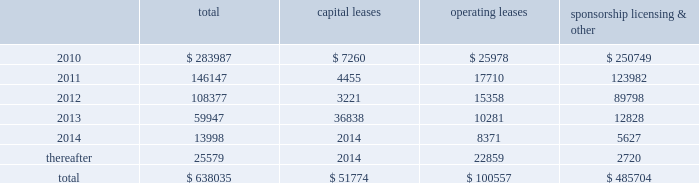Mastercard incorporated notes to consolidated financial statements 2014 ( continued ) ( in thousands , except percent and per share data ) equity awards was $ 30333 , $ 20726 and $ 19828 for the years ended december 31 , 2009 , 2008 and 2007 , respectively .
The income tax benefit related to options exercised during 2009 was $ 7545 .
The additional paid-in capital balance attributed to the equity awards was $ 197350 , $ 135538 and $ 114637 as of december 31 , 2009 , 2008 and 2007 , respectively .
On july 18 , 2006 , the company 2019s stockholders approved the mastercard incorporated 2006 non-employee director equity compensation plan ( the 201cdirector plan 201d ) .
The director plan provides for awards of deferred stock units ( 201cdsus 201d ) to each director of the company who is not a current employee of the company .
There are 100 shares of class a common stock reserved for dsu awards under the director plan .
During the years ended december 31 , 2009 , 2008 and 2007 , the company granted 7 dsus , 4 dsus and 8 dsus , respectively .
The fair value of the dsus was based on the closing stock price on the new york stock exchange of the company 2019s class a common stock on the date of grant .
The weighted average grant-date fair value of dsus granted during the years ended december 31 , 2009 , 2008 and 2007 was $ 168.18 , $ 284.92 and $ 139.27 , respectively .
The dsus vested immediately upon grant and will be settled in shares of the company 2019s class a common stock on the fourth anniversary of the date of grant .
Accordingly , the company recorded general and administrative expense of $ 1151 , $ 1209 and $ 1051 for the dsus for the years ended december 31 , 2009 , 2008 and 2007 , respectively .
The total income tax benefit recognized in the income statement for dsus was $ 410 , $ 371 and $ 413 for the years ended december 31 , 2009 , 2008 and 2007 , respectively .
Note 18 .
Commitments at december 31 , 2009 , the company had the following future minimum payments due under non-cancelable agreements : capital leases operating leases sponsorship , licensing & .
Included in the table above are capital leases with imputed interest expense of $ 7929 and a net present value of minimum lease payments of $ 43845 .
In addition , at december 31 , 2009 , $ 63616 of the future minimum payments in the table above for leases , sponsorship , licensing and other agreements was accrued .
Consolidated rental expense for the company 2019s office space , which is recognized on a straight line basis over the life of the lease , was approximately $ 39586 , $ 42905 and $ 35614 for the years ended december 31 , 2009 , 2008 and 2007 , respectively .
Consolidated lease expense for automobiles , computer equipment and office equipment was $ 9137 , $ 7694 and $ 7679 for the years ended december 31 , 2009 , 2008 and 2007 , respectively .
In january 2003 , mastercard purchased a building in kansas city , missouri for approximately $ 23572 .
The building is a co-processing data center which replaced a back-up data center in lake success , new york .
During 2003 , mastercard entered into agreements with the city of kansas city for ( i ) the sale-leaseback of the building and related equipment which totaled $ 36382 and ( ii ) the purchase of municipal bonds for the same amount .
What is the average value of operating leases during 2010-2014? 
Rationale: it is the sum of all operating leases during this period divided by six .
Computations: (100557 / 6)
Answer: 16759.5. Mastercard incorporated notes to consolidated financial statements 2014 ( continued ) ( in thousands , except percent and per share data ) equity awards was $ 30333 , $ 20726 and $ 19828 for the years ended december 31 , 2009 , 2008 and 2007 , respectively .
The income tax benefit related to options exercised during 2009 was $ 7545 .
The additional paid-in capital balance attributed to the equity awards was $ 197350 , $ 135538 and $ 114637 as of december 31 , 2009 , 2008 and 2007 , respectively .
On july 18 , 2006 , the company 2019s stockholders approved the mastercard incorporated 2006 non-employee director equity compensation plan ( the 201cdirector plan 201d ) .
The director plan provides for awards of deferred stock units ( 201cdsus 201d ) to each director of the company who is not a current employee of the company .
There are 100 shares of class a common stock reserved for dsu awards under the director plan .
During the years ended december 31 , 2009 , 2008 and 2007 , the company granted 7 dsus , 4 dsus and 8 dsus , respectively .
The fair value of the dsus was based on the closing stock price on the new york stock exchange of the company 2019s class a common stock on the date of grant .
The weighted average grant-date fair value of dsus granted during the years ended december 31 , 2009 , 2008 and 2007 was $ 168.18 , $ 284.92 and $ 139.27 , respectively .
The dsus vested immediately upon grant and will be settled in shares of the company 2019s class a common stock on the fourth anniversary of the date of grant .
Accordingly , the company recorded general and administrative expense of $ 1151 , $ 1209 and $ 1051 for the dsus for the years ended december 31 , 2009 , 2008 and 2007 , respectively .
The total income tax benefit recognized in the income statement for dsus was $ 410 , $ 371 and $ 413 for the years ended december 31 , 2009 , 2008 and 2007 , respectively .
Note 18 .
Commitments at december 31 , 2009 , the company had the following future minimum payments due under non-cancelable agreements : capital leases operating leases sponsorship , licensing & .
Included in the table above are capital leases with imputed interest expense of $ 7929 and a net present value of minimum lease payments of $ 43845 .
In addition , at december 31 , 2009 , $ 63616 of the future minimum payments in the table above for leases , sponsorship , licensing and other agreements was accrued .
Consolidated rental expense for the company 2019s office space , which is recognized on a straight line basis over the life of the lease , was approximately $ 39586 , $ 42905 and $ 35614 for the years ended december 31 , 2009 , 2008 and 2007 , respectively .
Consolidated lease expense for automobiles , computer equipment and office equipment was $ 9137 , $ 7694 and $ 7679 for the years ended december 31 , 2009 , 2008 and 2007 , respectively .
In january 2003 , mastercard purchased a building in kansas city , missouri for approximately $ 23572 .
The building is a co-processing data center which replaced a back-up data center in lake success , new york .
During 2003 , mastercard entered into agreements with the city of kansas city for ( i ) the sale-leaseback of the building and related equipment which totaled $ 36382 and ( ii ) the purchase of municipal bonds for the same amount .
What was the average rental expense from 2007 to 2009? 
Computations: ((((39586 + 42905) + 35614) + 3) / 2)
Answer: 59054.0. 